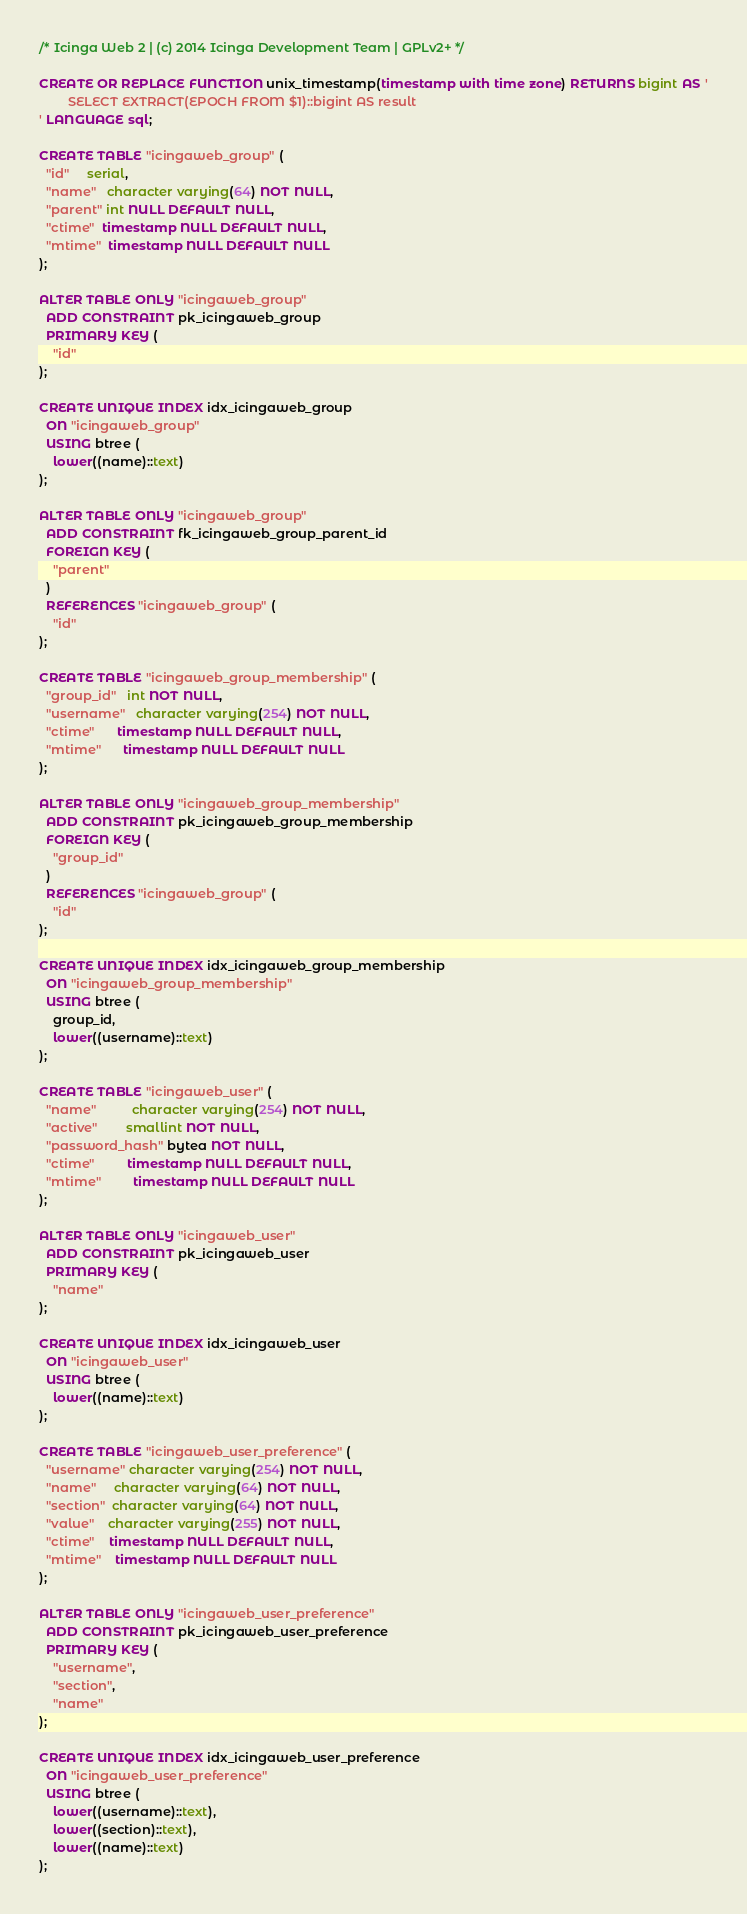<code> <loc_0><loc_0><loc_500><loc_500><_SQL_>/* Icinga Web 2 | (c) 2014 Icinga Development Team | GPLv2+ */

CREATE OR REPLACE FUNCTION unix_timestamp(timestamp with time zone) RETURNS bigint AS '
        SELECT EXTRACT(EPOCH FROM $1)::bigint AS result
' LANGUAGE sql;

CREATE TABLE "icingaweb_group" (
  "id"     serial,
  "name"   character varying(64) NOT NULL,
  "parent" int NULL DEFAULT NULL,
  "ctime"  timestamp NULL DEFAULT NULL,
  "mtime"  timestamp NULL DEFAULT NULL
);

ALTER TABLE ONLY "icingaweb_group"
  ADD CONSTRAINT pk_icingaweb_group
  PRIMARY KEY (
    "id"
);

CREATE UNIQUE INDEX idx_icingaweb_group
  ON "icingaweb_group"
  USING btree (
    lower((name)::text)
);

ALTER TABLE ONLY "icingaweb_group"
  ADD CONSTRAINT fk_icingaweb_group_parent_id
  FOREIGN KEY (
    "parent"
  )
  REFERENCES "icingaweb_group" (
    "id"
);

CREATE TABLE "icingaweb_group_membership" (
  "group_id"   int NOT NULL,
  "username"   character varying(254) NOT NULL,
  "ctime"      timestamp NULL DEFAULT NULL,
  "mtime"      timestamp NULL DEFAULT NULL
);

ALTER TABLE ONLY "icingaweb_group_membership"
  ADD CONSTRAINT pk_icingaweb_group_membership
  FOREIGN KEY (
    "group_id"
  )
  REFERENCES "icingaweb_group" (
    "id"
);

CREATE UNIQUE INDEX idx_icingaweb_group_membership
  ON "icingaweb_group_membership"
  USING btree (
    group_id,
    lower((username)::text)
);

CREATE TABLE "icingaweb_user" (
  "name"          character varying(254) NOT NULL,
  "active"        smallint NOT NULL,
  "password_hash" bytea NOT NULL,
  "ctime"         timestamp NULL DEFAULT NULL,
  "mtime"         timestamp NULL DEFAULT NULL
);

ALTER TABLE ONLY "icingaweb_user"
  ADD CONSTRAINT pk_icingaweb_user
  PRIMARY KEY (
    "name"
);

CREATE UNIQUE INDEX idx_icingaweb_user
  ON "icingaweb_user"
  USING btree (
    lower((name)::text)
);

CREATE TABLE "icingaweb_user_preference" (
  "username" character varying(254) NOT NULL,
  "name"     character varying(64) NOT NULL,
  "section"  character varying(64) NOT NULL,
  "value"    character varying(255) NOT NULL,
  "ctime"    timestamp NULL DEFAULT NULL,
  "mtime"    timestamp NULL DEFAULT NULL
);

ALTER TABLE ONLY "icingaweb_user_preference"
  ADD CONSTRAINT pk_icingaweb_user_preference
  PRIMARY KEY (
    "username",
    "section",
    "name"
);

CREATE UNIQUE INDEX idx_icingaweb_user_preference
  ON "icingaweb_user_preference"
  USING btree (
    lower((username)::text),
    lower((section)::text),
    lower((name)::text)
);
</code> 